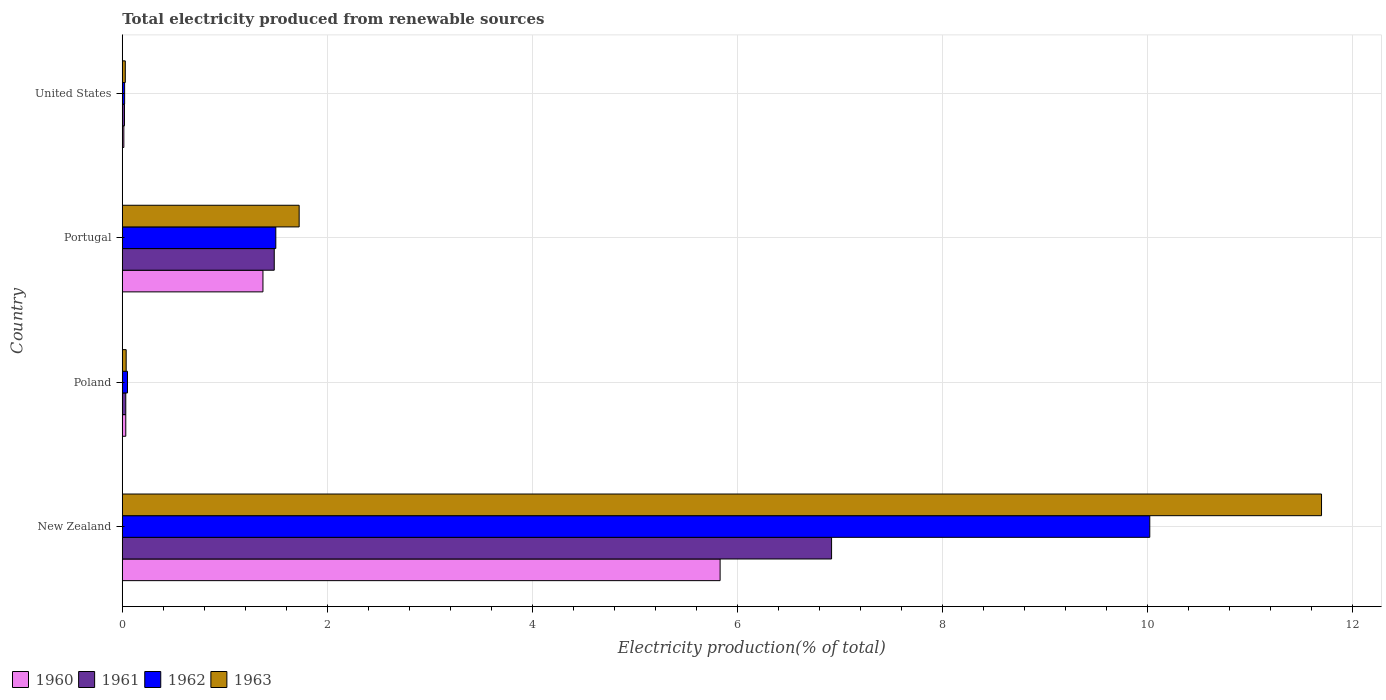How many groups of bars are there?
Give a very brief answer. 4. How many bars are there on the 4th tick from the bottom?
Your answer should be compact. 4. What is the label of the 3rd group of bars from the top?
Give a very brief answer. Poland. In how many cases, is the number of bars for a given country not equal to the number of legend labels?
Offer a terse response. 0. What is the total electricity produced in 1960 in New Zealand?
Offer a terse response. 5.83. Across all countries, what is the maximum total electricity produced in 1961?
Ensure brevity in your answer.  6.92. Across all countries, what is the minimum total electricity produced in 1961?
Your answer should be very brief. 0.02. In which country was the total electricity produced in 1961 maximum?
Provide a short and direct response. New Zealand. In which country was the total electricity produced in 1962 minimum?
Your response must be concise. United States. What is the total total electricity produced in 1961 in the graph?
Give a very brief answer. 8.46. What is the difference between the total electricity produced in 1961 in New Zealand and that in United States?
Ensure brevity in your answer.  6.9. What is the difference between the total electricity produced in 1963 in United States and the total electricity produced in 1961 in Portugal?
Your response must be concise. -1.45. What is the average total electricity produced in 1962 per country?
Provide a short and direct response. 2.9. What is the difference between the total electricity produced in 1962 and total electricity produced in 1960 in Poland?
Make the answer very short. 0.02. In how many countries, is the total electricity produced in 1961 greater than 6 %?
Keep it short and to the point. 1. What is the ratio of the total electricity produced in 1960 in New Zealand to that in United States?
Provide a succinct answer. 382.31. What is the difference between the highest and the second highest total electricity produced in 1961?
Provide a succinct answer. 5.44. What is the difference between the highest and the lowest total electricity produced in 1962?
Provide a succinct answer. 10. How many countries are there in the graph?
Offer a terse response. 4. Are the values on the major ticks of X-axis written in scientific E-notation?
Provide a short and direct response. No. Does the graph contain any zero values?
Your answer should be very brief. No. How many legend labels are there?
Provide a short and direct response. 4. What is the title of the graph?
Your answer should be compact. Total electricity produced from renewable sources. Does "1980" appear as one of the legend labels in the graph?
Make the answer very short. No. What is the label or title of the X-axis?
Give a very brief answer. Electricity production(% of total). What is the Electricity production(% of total) of 1960 in New Zealand?
Make the answer very short. 5.83. What is the Electricity production(% of total) of 1961 in New Zealand?
Keep it short and to the point. 6.92. What is the Electricity production(% of total) in 1962 in New Zealand?
Provide a short and direct response. 10.02. What is the Electricity production(% of total) in 1963 in New Zealand?
Your response must be concise. 11.7. What is the Electricity production(% of total) of 1960 in Poland?
Ensure brevity in your answer.  0.03. What is the Electricity production(% of total) of 1961 in Poland?
Offer a very short reply. 0.03. What is the Electricity production(% of total) of 1962 in Poland?
Keep it short and to the point. 0.05. What is the Electricity production(% of total) of 1963 in Poland?
Provide a short and direct response. 0.04. What is the Electricity production(% of total) of 1960 in Portugal?
Your response must be concise. 1.37. What is the Electricity production(% of total) of 1961 in Portugal?
Your response must be concise. 1.48. What is the Electricity production(% of total) in 1962 in Portugal?
Your answer should be compact. 1.5. What is the Electricity production(% of total) in 1963 in Portugal?
Your answer should be very brief. 1.73. What is the Electricity production(% of total) in 1960 in United States?
Your response must be concise. 0.02. What is the Electricity production(% of total) in 1961 in United States?
Give a very brief answer. 0.02. What is the Electricity production(% of total) of 1962 in United States?
Give a very brief answer. 0.02. What is the Electricity production(% of total) in 1963 in United States?
Ensure brevity in your answer.  0.03. Across all countries, what is the maximum Electricity production(% of total) of 1960?
Your answer should be very brief. 5.83. Across all countries, what is the maximum Electricity production(% of total) in 1961?
Give a very brief answer. 6.92. Across all countries, what is the maximum Electricity production(% of total) in 1962?
Give a very brief answer. 10.02. Across all countries, what is the maximum Electricity production(% of total) in 1963?
Give a very brief answer. 11.7. Across all countries, what is the minimum Electricity production(% of total) of 1960?
Your response must be concise. 0.02. Across all countries, what is the minimum Electricity production(% of total) of 1961?
Your answer should be compact. 0.02. Across all countries, what is the minimum Electricity production(% of total) in 1962?
Your answer should be compact. 0.02. Across all countries, what is the minimum Electricity production(% of total) in 1963?
Provide a short and direct response. 0.03. What is the total Electricity production(% of total) in 1960 in the graph?
Ensure brevity in your answer.  7.25. What is the total Electricity production(% of total) of 1961 in the graph?
Offer a terse response. 8.46. What is the total Electricity production(% of total) of 1962 in the graph?
Make the answer very short. 11.6. What is the total Electricity production(% of total) in 1963 in the graph?
Give a very brief answer. 13.49. What is the difference between the Electricity production(% of total) of 1960 in New Zealand and that in Poland?
Provide a succinct answer. 5.8. What is the difference between the Electricity production(% of total) of 1961 in New Zealand and that in Poland?
Provide a succinct answer. 6.89. What is the difference between the Electricity production(% of total) of 1962 in New Zealand and that in Poland?
Offer a terse response. 9.97. What is the difference between the Electricity production(% of total) in 1963 in New Zealand and that in Poland?
Make the answer very short. 11.66. What is the difference between the Electricity production(% of total) of 1960 in New Zealand and that in Portugal?
Keep it short and to the point. 4.46. What is the difference between the Electricity production(% of total) in 1961 in New Zealand and that in Portugal?
Make the answer very short. 5.44. What is the difference between the Electricity production(% of total) of 1962 in New Zealand and that in Portugal?
Your response must be concise. 8.53. What is the difference between the Electricity production(% of total) in 1963 in New Zealand and that in Portugal?
Provide a short and direct response. 9.97. What is the difference between the Electricity production(% of total) of 1960 in New Zealand and that in United States?
Provide a short and direct response. 5.82. What is the difference between the Electricity production(% of total) in 1961 in New Zealand and that in United States?
Keep it short and to the point. 6.9. What is the difference between the Electricity production(% of total) of 1962 in New Zealand and that in United States?
Give a very brief answer. 10. What is the difference between the Electricity production(% of total) in 1963 in New Zealand and that in United States?
Offer a very short reply. 11.67. What is the difference between the Electricity production(% of total) of 1960 in Poland and that in Portugal?
Make the answer very short. -1.34. What is the difference between the Electricity production(% of total) of 1961 in Poland and that in Portugal?
Offer a very short reply. -1.45. What is the difference between the Electricity production(% of total) of 1962 in Poland and that in Portugal?
Your answer should be compact. -1.45. What is the difference between the Electricity production(% of total) of 1963 in Poland and that in Portugal?
Your answer should be very brief. -1.69. What is the difference between the Electricity production(% of total) of 1960 in Poland and that in United States?
Your response must be concise. 0.02. What is the difference between the Electricity production(% of total) of 1961 in Poland and that in United States?
Keep it short and to the point. 0.01. What is the difference between the Electricity production(% of total) in 1962 in Poland and that in United States?
Make the answer very short. 0.03. What is the difference between the Electricity production(% of total) of 1963 in Poland and that in United States?
Make the answer very short. 0.01. What is the difference between the Electricity production(% of total) of 1960 in Portugal and that in United States?
Provide a short and direct response. 1.36. What is the difference between the Electricity production(% of total) of 1961 in Portugal and that in United States?
Make the answer very short. 1.46. What is the difference between the Electricity production(% of total) in 1962 in Portugal and that in United States?
Offer a terse response. 1.48. What is the difference between the Electricity production(% of total) of 1963 in Portugal and that in United States?
Make the answer very short. 1.7. What is the difference between the Electricity production(% of total) of 1960 in New Zealand and the Electricity production(% of total) of 1961 in Poland?
Your answer should be very brief. 5.8. What is the difference between the Electricity production(% of total) of 1960 in New Zealand and the Electricity production(% of total) of 1962 in Poland?
Give a very brief answer. 5.78. What is the difference between the Electricity production(% of total) of 1960 in New Zealand and the Electricity production(% of total) of 1963 in Poland?
Offer a terse response. 5.79. What is the difference between the Electricity production(% of total) in 1961 in New Zealand and the Electricity production(% of total) in 1962 in Poland?
Give a very brief answer. 6.87. What is the difference between the Electricity production(% of total) in 1961 in New Zealand and the Electricity production(% of total) in 1963 in Poland?
Offer a terse response. 6.88. What is the difference between the Electricity production(% of total) of 1962 in New Zealand and the Electricity production(% of total) of 1963 in Poland?
Provide a succinct answer. 9.99. What is the difference between the Electricity production(% of total) in 1960 in New Zealand and the Electricity production(% of total) in 1961 in Portugal?
Provide a short and direct response. 4.35. What is the difference between the Electricity production(% of total) in 1960 in New Zealand and the Electricity production(% of total) in 1962 in Portugal?
Your answer should be very brief. 4.33. What is the difference between the Electricity production(% of total) of 1960 in New Zealand and the Electricity production(% of total) of 1963 in Portugal?
Ensure brevity in your answer.  4.11. What is the difference between the Electricity production(% of total) of 1961 in New Zealand and the Electricity production(% of total) of 1962 in Portugal?
Your response must be concise. 5.42. What is the difference between the Electricity production(% of total) of 1961 in New Zealand and the Electricity production(% of total) of 1963 in Portugal?
Offer a terse response. 5.19. What is the difference between the Electricity production(% of total) in 1962 in New Zealand and the Electricity production(% of total) in 1963 in Portugal?
Offer a terse response. 8.3. What is the difference between the Electricity production(% of total) of 1960 in New Zealand and the Electricity production(% of total) of 1961 in United States?
Your answer should be very brief. 5.81. What is the difference between the Electricity production(% of total) of 1960 in New Zealand and the Electricity production(% of total) of 1962 in United States?
Give a very brief answer. 5.81. What is the difference between the Electricity production(% of total) of 1960 in New Zealand and the Electricity production(% of total) of 1963 in United States?
Ensure brevity in your answer.  5.8. What is the difference between the Electricity production(% of total) of 1961 in New Zealand and the Electricity production(% of total) of 1962 in United States?
Keep it short and to the point. 6.9. What is the difference between the Electricity production(% of total) of 1961 in New Zealand and the Electricity production(% of total) of 1963 in United States?
Offer a very short reply. 6.89. What is the difference between the Electricity production(% of total) in 1962 in New Zealand and the Electricity production(% of total) in 1963 in United States?
Your answer should be very brief. 10. What is the difference between the Electricity production(% of total) in 1960 in Poland and the Electricity production(% of total) in 1961 in Portugal?
Give a very brief answer. -1.45. What is the difference between the Electricity production(% of total) of 1960 in Poland and the Electricity production(% of total) of 1962 in Portugal?
Offer a very short reply. -1.46. What is the difference between the Electricity production(% of total) in 1960 in Poland and the Electricity production(% of total) in 1963 in Portugal?
Your answer should be very brief. -1.69. What is the difference between the Electricity production(% of total) in 1961 in Poland and the Electricity production(% of total) in 1962 in Portugal?
Keep it short and to the point. -1.46. What is the difference between the Electricity production(% of total) of 1961 in Poland and the Electricity production(% of total) of 1963 in Portugal?
Make the answer very short. -1.69. What is the difference between the Electricity production(% of total) in 1962 in Poland and the Electricity production(% of total) in 1963 in Portugal?
Ensure brevity in your answer.  -1.67. What is the difference between the Electricity production(% of total) in 1960 in Poland and the Electricity production(% of total) in 1961 in United States?
Provide a succinct answer. 0.01. What is the difference between the Electricity production(% of total) of 1960 in Poland and the Electricity production(% of total) of 1962 in United States?
Provide a succinct answer. 0.01. What is the difference between the Electricity production(% of total) in 1960 in Poland and the Electricity production(% of total) in 1963 in United States?
Give a very brief answer. 0. What is the difference between the Electricity production(% of total) in 1961 in Poland and the Electricity production(% of total) in 1962 in United States?
Make the answer very short. 0.01. What is the difference between the Electricity production(% of total) of 1961 in Poland and the Electricity production(% of total) of 1963 in United States?
Offer a terse response. 0. What is the difference between the Electricity production(% of total) in 1962 in Poland and the Electricity production(% of total) in 1963 in United States?
Your answer should be compact. 0.02. What is the difference between the Electricity production(% of total) in 1960 in Portugal and the Electricity production(% of total) in 1961 in United States?
Provide a short and direct response. 1.35. What is the difference between the Electricity production(% of total) in 1960 in Portugal and the Electricity production(% of total) in 1962 in United States?
Provide a succinct answer. 1.35. What is the difference between the Electricity production(% of total) in 1960 in Portugal and the Electricity production(% of total) in 1963 in United States?
Your response must be concise. 1.34. What is the difference between the Electricity production(% of total) of 1961 in Portugal and the Electricity production(% of total) of 1962 in United States?
Your response must be concise. 1.46. What is the difference between the Electricity production(% of total) in 1961 in Portugal and the Electricity production(% of total) in 1963 in United States?
Your answer should be compact. 1.45. What is the difference between the Electricity production(% of total) of 1962 in Portugal and the Electricity production(% of total) of 1963 in United States?
Your response must be concise. 1.47. What is the average Electricity production(% of total) of 1960 per country?
Make the answer very short. 1.81. What is the average Electricity production(% of total) of 1961 per country?
Give a very brief answer. 2.11. What is the average Electricity production(% of total) in 1962 per country?
Your answer should be very brief. 2.9. What is the average Electricity production(% of total) in 1963 per country?
Provide a short and direct response. 3.37. What is the difference between the Electricity production(% of total) in 1960 and Electricity production(% of total) in 1961 in New Zealand?
Give a very brief answer. -1.09. What is the difference between the Electricity production(% of total) in 1960 and Electricity production(% of total) in 1962 in New Zealand?
Your response must be concise. -4.19. What is the difference between the Electricity production(% of total) of 1960 and Electricity production(% of total) of 1963 in New Zealand?
Your answer should be very brief. -5.87. What is the difference between the Electricity production(% of total) of 1961 and Electricity production(% of total) of 1962 in New Zealand?
Offer a terse response. -3.1. What is the difference between the Electricity production(% of total) in 1961 and Electricity production(% of total) in 1963 in New Zealand?
Make the answer very short. -4.78. What is the difference between the Electricity production(% of total) in 1962 and Electricity production(% of total) in 1963 in New Zealand?
Your answer should be compact. -1.68. What is the difference between the Electricity production(% of total) in 1960 and Electricity production(% of total) in 1961 in Poland?
Your answer should be very brief. 0. What is the difference between the Electricity production(% of total) of 1960 and Electricity production(% of total) of 1962 in Poland?
Keep it short and to the point. -0.02. What is the difference between the Electricity production(% of total) of 1960 and Electricity production(% of total) of 1963 in Poland?
Ensure brevity in your answer.  -0. What is the difference between the Electricity production(% of total) of 1961 and Electricity production(% of total) of 1962 in Poland?
Provide a succinct answer. -0.02. What is the difference between the Electricity production(% of total) of 1961 and Electricity production(% of total) of 1963 in Poland?
Offer a very short reply. -0. What is the difference between the Electricity production(% of total) in 1962 and Electricity production(% of total) in 1963 in Poland?
Make the answer very short. 0.01. What is the difference between the Electricity production(% of total) of 1960 and Electricity production(% of total) of 1961 in Portugal?
Keep it short and to the point. -0.11. What is the difference between the Electricity production(% of total) of 1960 and Electricity production(% of total) of 1962 in Portugal?
Give a very brief answer. -0.13. What is the difference between the Electricity production(% of total) in 1960 and Electricity production(% of total) in 1963 in Portugal?
Give a very brief answer. -0.35. What is the difference between the Electricity production(% of total) in 1961 and Electricity production(% of total) in 1962 in Portugal?
Provide a succinct answer. -0.02. What is the difference between the Electricity production(% of total) in 1961 and Electricity production(% of total) in 1963 in Portugal?
Your answer should be very brief. -0.24. What is the difference between the Electricity production(% of total) of 1962 and Electricity production(% of total) of 1963 in Portugal?
Give a very brief answer. -0.23. What is the difference between the Electricity production(% of total) of 1960 and Electricity production(% of total) of 1961 in United States?
Give a very brief answer. -0.01. What is the difference between the Electricity production(% of total) in 1960 and Electricity production(% of total) in 1962 in United States?
Your answer should be compact. -0.01. What is the difference between the Electricity production(% of total) in 1960 and Electricity production(% of total) in 1963 in United States?
Provide a succinct answer. -0.01. What is the difference between the Electricity production(% of total) of 1961 and Electricity production(% of total) of 1962 in United States?
Provide a succinct answer. -0. What is the difference between the Electricity production(% of total) of 1961 and Electricity production(% of total) of 1963 in United States?
Provide a short and direct response. -0.01. What is the difference between the Electricity production(% of total) in 1962 and Electricity production(% of total) in 1963 in United States?
Your answer should be very brief. -0.01. What is the ratio of the Electricity production(% of total) in 1960 in New Zealand to that in Poland?
Provide a succinct answer. 170.79. What is the ratio of the Electricity production(% of total) in 1961 in New Zealand to that in Poland?
Your answer should be very brief. 202.83. What is the ratio of the Electricity production(% of total) in 1962 in New Zealand to that in Poland?
Offer a very short reply. 196.95. What is the ratio of the Electricity production(% of total) of 1963 in New Zealand to that in Poland?
Give a very brief answer. 308.73. What is the ratio of the Electricity production(% of total) in 1960 in New Zealand to that in Portugal?
Provide a short and direct response. 4.25. What is the ratio of the Electricity production(% of total) in 1961 in New Zealand to that in Portugal?
Your response must be concise. 4.67. What is the ratio of the Electricity production(% of total) in 1962 in New Zealand to that in Portugal?
Keep it short and to the point. 6.69. What is the ratio of the Electricity production(% of total) in 1963 in New Zealand to that in Portugal?
Keep it short and to the point. 6.78. What is the ratio of the Electricity production(% of total) in 1960 in New Zealand to that in United States?
Your answer should be compact. 382.31. What is the ratio of the Electricity production(% of total) in 1961 in New Zealand to that in United States?
Your answer should be compact. 321.25. What is the ratio of the Electricity production(% of total) in 1962 in New Zealand to that in United States?
Keep it short and to the point. 439.93. What is the ratio of the Electricity production(% of total) of 1963 in New Zealand to that in United States?
Offer a terse response. 397.5. What is the ratio of the Electricity production(% of total) in 1960 in Poland to that in Portugal?
Make the answer very short. 0.02. What is the ratio of the Electricity production(% of total) of 1961 in Poland to that in Portugal?
Give a very brief answer. 0.02. What is the ratio of the Electricity production(% of total) in 1962 in Poland to that in Portugal?
Offer a terse response. 0.03. What is the ratio of the Electricity production(% of total) in 1963 in Poland to that in Portugal?
Your response must be concise. 0.02. What is the ratio of the Electricity production(% of total) of 1960 in Poland to that in United States?
Provide a succinct answer. 2.24. What is the ratio of the Electricity production(% of total) of 1961 in Poland to that in United States?
Your answer should be very brief. 1.58. What is the ratio of the Electricity production(% of total) in 1962 in Poland to that in United States?
Provide a succinct answer. 2.23. What is the ratio of the Electricity production(% of total) of 1963 in Poland to that in United States?
Provide a succinct answer. 1.29. What is the ratio of the Electricity production(% of total) of 1960 in Portugal to that in United States?
Provide a short and direct response. 89.96. What is the ratio of the Electricity production(% of total) of 1961 in Portugal to that in United States?
Give a very brief answer. 68.83. What is the ratio of the Electricity production(% of total) in 1962 in Portugal to that in United States?
Keep it short and to the point. 65.74. What is the ratio of the Electricity production(% of total) of 1963 in Portugal to that in United States?
Make the answer very short. 58.63. What is the difference between the highest and the second highest Electricity production(% of total) in 1960?
Offer a terse response. 4.46. What is the difference between the highest and the second highest Electricity production(% of total) of 1961?
Ensure brevity in your answer.  5.44. What is the difference between the highest and the second highest Electricity production(% of total) of 1962?
Your answer should be compact. 8.53. What is the difference between the highest and the second highest Electricity production(% of total) in 1963?
Provide a succinct answer. 9.97. What is the difference between the highest and the lowest Electricity production(% of total) in 1960?
Provide a short and direct response. 5.82. What is the difference between the highest and the lowest Electricity production(% of total) of 1961?
Offer a very short reply. 6.9. What is the difference between the highest and the lowest Electricity production(% of total) of 1962?
Give a very brief answer. 10. What is the difference between the highest and the lowest Electricity production(% of total) of 1963?
Offer a terse response. 11.67. 